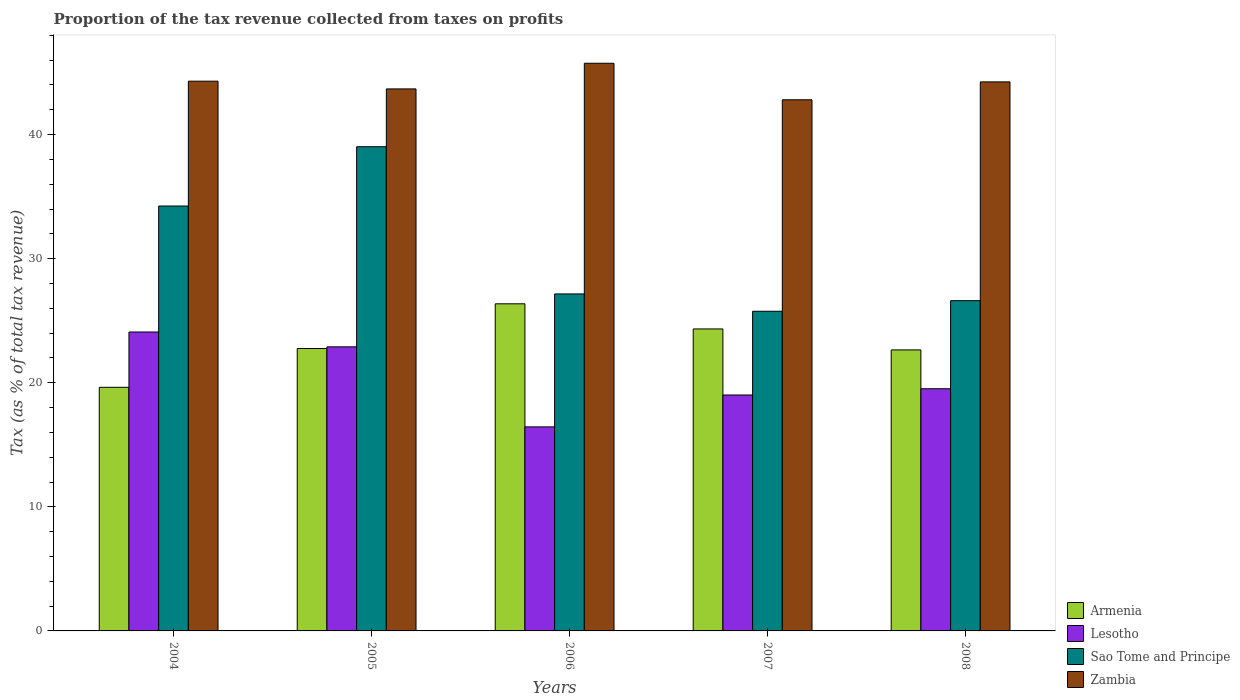How many different coloured bars are there?
Provide a short and direct response. 4. How many groups of bars are there?
Your answer should be very brief. 5. Are the number of bars on each tick of the X-axis equal?
Your answer should be very brief. Yes. In how many cases, is the number of bars for a given year not equal to the number of legend labels?
Offer a very short reply. 0. What is the proportion of the tax revenue collected in Zambia in 2008?
Your answer should be compact. 44.24. Across all years, what is the maximum proportion of the tax revenue collected in Lesotho?
Offer a terse response. 24.09. Across all years, what is the minimum proportion of the tax revenue collected in Armenia?
Make the answer very short. 19.63. In which year was the proportion of the tax revenue collected in Zambia minimum?
Your answer should be very brief. 2007. What is the total proportion of the tax revenue collected in Zambia in the graph?
Your answer should be compact. 220.77. What is the difference between the proportion of the tax revenue collected in Lesotho in 2004 and that in 2007?
Give a very brief answer. 5.07. What is the difference between the proportion of the tax revenue collected in Zambia in 2007 and the proportion of the tax revenue collected in Lesotho in 2005?
Make the answer very short. 19.91. What is the average proportion of the tax revenue collected in Armenia per year?
Ensure brevity in your answer.  23.15. In the year 2005, what is the difference between the proportion of the tax revenue collected in Lesotho and proportion of the tax revenue collected in Sao Tome and Principe?
Make the answer very short. -16.12. In how many years, is the proportion of the tax revenue collected in Sao Tome and Principe greater than 26 %?
Give a very brief answer. 4. What is the ratio of the proportion of the tax revenue collected in Zambia in 2006 to that in 2007?
Your answer should be compact. 1.07. What is the difference between the highest and the second highest proportion of the tax revenue collected in Sao Tome and Principe?
Provide a short and direct response. 4.78. What is the difference between the highest and the lowest proportion of the tax revenue collected in Lesotho?
Ensure brevity in your answer.  7.64. In how many years, is the proportion of the tax revenue collected in Lesotho greater than the average proportion of the tax revenue collected in Lesotho taken over all years?
Provide a succinct answer. 2. What does the 3rd bar from the left in 2008 represents?
Provide a short and direct response. Sao Tome and Principe. What does the 2nd bar from the right in 2007 represents?
Your response must be concise. Sao Tome and Principe. How many bars are there?
Keep it short and to the point. 20. Are all the bars in the graph horizontal?
Give a very brief answer. No. How many years are there in the graph?
Your response must be concise. 5. What is the difference between two consecutive major ticks on the Y-axis?
Give a very brief answer. 10. Are the values on the major ticks of Y-axis written in scientific E-notation?
Offer a very short reply. No. Does the graph contain grids?
Provide a succinct answer. No. Where does the legend appear in the graph?
Provide a short and direct response. Bottom right. How many legend labels are there?
Offer a very short reply. 4. What is the title of the graph?
Your answer should be very brief. Proportion of the tax revenue collected from taxes on profits. What is the label or title of the Y-axis?
Provide a short and direct response. Tax (as % of total tax revenue). What is the Tax (as % of total tax revenue) of Armenia in 2004?
Provide a succinct answer. 19.63. What is the Tax (as % of total tax revenue) in Lesotho in 2004?
Keep it short and to the point. 24.09. What is the Tax (as % of total tax revenue) in Sao Tome and Principe in 2004?
Your response must be concise. 34.24. What is the Tax (as % of total tax revenue) in Zambia in 2004?
Your answer should be very brief. 44.3. What is the Tax (as % of total tax revenue) in Armenia in 2005?
Provide a short and direct response. 22.76. What is the Tax (as % of total tax revenue) in Lesotho in 2005?
Keep it short and to the point. 22.89. What is the Tax (as % of total tax revenue) in Sao Tome and Principe in 2005?
Ensure brevity in your answer.  39.02. What is the Tax (as % of total tax revenue) in Zambia in 2005?
Your answer should be very brief. 43.68. What is the Tax (as % of total tax revenue) in Armenia in 2006?
Make the answer very short. 26.36. What is the Tax (as % of total tax revenue) in Lesotho in 2006?
Make the answer very short. 16.44. What is the Tax (as % of total tax revenue) of Sao Tome and Principe in 2006?
Provide a succinct answer. 27.16. What is the Tax (as % of total tax revenue) in Zambia in 2006?
Keep it short and to the point. 45.74. What is the Tax (as % of total tax revenue) in Armenia in 2007?
Give a very brief answer. 24.33. What is the Tax (as % of total tax revenue) in Lesotho in 2007?
Your answer should be compact. 19.01. What is the Tax (as % of total tax revenue) of Sao Tome and Principe in 2007?
Give a very brief answer. 25.76. What is the Tax (as % of total tax revenue) of Zambia in 2007?
Ensure brevity in your answer.  42.8. What is the Tax (as % of total tax revenue) in Armenia in 2008?
Provide a short and direct response. 22.64. What is the Tax (as % of total tax revenue) in Lesotho in 2008?
Your response must be concise. 19.52. What is the Tax (as % of total tax revenue) in Sao Tome and Principe in 2008?
Offer a terse response. 26.61. What is the Tax (as % of total tax revenue) in Zambia in 2008?
Ensure brevity in your answer.  44.24. Across all years, what is the maximum Tax (as % of total tax revenue) of Armenia?
Your response must be concise. 26.36. Across all years, what is the maximum Tax (as % of total tax revenue) of Lesotho?
Your answer should be compact. 24.09. Across all years, what is the maximum Tax (as % of total tax revenue) of Sao Tome and Principe?
Give a very brief answer. 39.02. Across all years, what is the maximum Tax (as % of total tax revenue) in Zambia?
Your response must be concise. 45.74. Across all years, what is the minimum Tax (as % of total tax revenue) in Armenia?
Offer a terse response. 19.63. Across all years, what is the minimum Tax (as % of total tax revenue) of Lesotho?
Provide a short and direct response. 16.44. Across all years, what is the minimum Tax (as % of total tax revenue) in Sao Tome and Principe?
Make the answer very short. 25.76. Across all years, what is the minimum Tax (as % of total tax revenue) of Zambia?
Keep it short and to the point. 42.8. What is the total Tax (as % of total tax revenue) in Armenia in the graph?
Your answer should be compact. 115.73. What is the total Tax (as % of total tax revenue) in Lesotho in the graph?
Your response must be concise. 101.95. What is the total Tax (as % of total tax revenue) in Sao Tome and Principe in the graph?
Offer a terse response. 152.78. What is the total Tax (as % of total tax revenue) in Zambia in the graph?
Your response must be concise. 220.77. What is the difference between the Tax (as % of total tax revenue) of Armenia in 2004 and that in 2005?
Provide a short and direct response. -3.13. What is the difference between the Tax (as % of total tax revenue) of Lesotho in 2004 and that in 2005?
Provide a succinct answer. 1.19. What is the difference between the Tax (as % of total tax revenue) of Sao Tome and Principe in 2004 and that in 2005?
Your answer should be compact. -4.78. What is the difference between the Tax (as % of total tax revenue) in Zambia in 2004 and that in 2005?
Make the answer very short. 0.62. What is the difference between the Tax (as % of total tax revenue) in Armenia in 2004 and that in 2006?
Make the answer very short. -6.73. What is the difference between the Tax (as % of total tax revenue) in Lesotho in 2004 and that in 2006?
Keep it short and to the point. 7.64. What is the difference between the Tax (as % of total tax revenue) in Sao Tome and Principe in 2004 and that in 2006?
Make the answer very short. 7.08. What is the difference between the Tax (as % of total tax revenue) in Zambia in 2004 and that in 2006?
Make the answer very short. -1.44. What is the difference between the Tax (as % of total tax revenue) of Armenia in 2004 and that in 2007?
Make the answer very short. -4.7. What is the difference between the Tax (as % of total tax revenue) in Lesotho in 2004 and that in 2007?
Provide a short and direct response. 5.07. What is the difference between the Tax (as % of total tax revenue) in Sao Tome and Principe in 2004 and that in 2007?
Your response must be concise. 8.48. What is the difference between the Tax (as % of total tax revenue) of Zambia in 2004 and that in 2007?
Keep it short and to the point. 1.5. What is the difference between the Tax (as % of total tax revenue) in Armenia in 2004 and that in 2008?
Your response must be concise. -3.01. What is the difference between the Tax (as % of total tax revenue) in Lesotho in 2004 and that in 2008?
Provide a succinct answer. 4.57. What is the difference between the Tax (as % of total tax revenue) of Sao Tome and Principe in 2004 and that in 2008?
Provide a succinct answer. 7.63. What is the difference between the Tax (as % of total tax revenue) in Zambia in 2004 and that in 2008?
Ensure brevity in your answer.  0.06. What is the difference between the Tax (as % of total tax revenue) of Armenia in 2005 and that in 2006?
Your answer should be compact. -3.6. What is the difference between the Tax (as % of total tax revenue) of Lesotho in 2005 and that in 2006?
Ensure brevity in your answer.  6.45. What is the difference between the Tax (as % of total tax revenue) of Sao Tome and Principe in 2005 and that in 2006?
Provide a succinct answer. 11.86. What is the difference between the Tax (as % of total tax revenue) in Zambia in 2005 and that in 2006?
Make the answer very short. -2.07. What is the difference between the Tax (as % of total tax revenue) in Armenia in 2005 and that in 2007?
Keep it short and to the point. -1.58. What is the difference between the Tax (as % of total tax revenue) in Lesotho in 2005 and that in 2007?
Your answer should be very brief. 3.88. What is the difference between the Tax (as % of total tax revenue) of Sao Tome and Principe in 2005 and that in 2007?
Keep it short and to the point. 13.26. What is the difference between the Tax (as % of total tax revenue) of Zambia in 2005 and that in 2007?
Give a very brief answer. 0.88. What is the difference between the Tax (as % of total tax revenue) of Armenia in 2005 and that in 2008?
Keep it short and to the point. 0.11. What is the difference between the Tax (as % of total tax revenue) of Lesotho in 2005 and that in 2008?
Give a very brief answer. 3.38. What is the difference between the Tax (as % of total tax revenue) in Sao Tome and Principe in 2005 and that in 2008?
Offer a terse response. 12.41. What is the difference between the Tax (as % of total tax revenue) in Zambia in 2005 and that in 2008?
Ensure brevity in your answer.  -0.57. What is the difference between the Tax (as % of total tax revenue) of Armenia in 2006 and that in 2007?
Keep it short and to the point. 2.03. What is the difference between the Tax (as % of total tax revenue) in Lesotho in 2006 and that in 2007?
Offer a very short reply. -2.57. What is the difference between the Tax (as % of total tax revenue) of Sao Tome and Principe in 2006 and that in 2007?
Provide a succinct answer. 1.4. What is the difference between the Tax (as % of total tax revenue) of Zambia in 2006 and that in 2007?
Make the answer very short. 2.94. What is the difference between the Tax (as % of total tax revenue) in Armenia in 2006 and that in 2008?
Your answer should be very brief. 3.72. What is the difference between the Tax (as % of total tax revenue) in Lesotho in 2006 and that in 2008?
Provide a short and direct response. -3.07. What is the difference between the Tax (as % of total tax revenue) of Sao Tome and Principe in 2006 and that in 2008?
Provide a succinct answer. 0.54. What is the difference between the Tax (as % of total tax revenue) of Zambia in 2006 and that in 2008?
Your response must be concise. 1.5. What is the difference between the Tax (as % of total tax revenue) in Armenia in 2007 and that in 2008?
Offer a terse response. 1.69. What is the difference between the Tax (as % of total tax revenue) of Lesotho in 2007 and that in 2008?
Provide a succinct answer. -0.5. What is the difference between the Tax (as % of total tax revenue) of Sao Tome and Principe in 2007 and that in 2008?
Make the answer very short. -0.85. What is the difference between the Tax (as % of total tax revenue) in Zambia in 2007 and that in 2008?
Your answer should be very brief. -1.44. What is the difference between the Tax (as % of total tax revenue) in Armenia in 2004 and the Tax (as % of total tax revenue) in Lesotho in 2005?
Keep it short and to the point. -3.26. What is the difference between the Tax (as % of total tax revenue) in Armenia in 2004 and the Tax (as % of total tax revenue) in Sao Tome and Principe in 2005?
Your answer should be very brief. -19.39. What is the difference between the Tax (as % of total tax revenue) of Armenia in 2004 and the Tax (as % of total tax revenue) of Zambia in 2005?
Offer a very short reply. -24.05. What is the difference between the Tax (as % of total tax revenue) in Lesotho in 2004 and the Tax (as % of total tax revenue) in Sao Tome and Principe in 2005?
Your answer should be compact. -14.93. What is the difference between the Tax (as % of total tax revenue) of Lesotho in 2004 and the Tax (as % of total tax revenue) of Zambia in 2005?
Give a very brief answer. -19.59. What is the difference between the Tax (as % of total tax revenue) in Sao Tome and Principe in 2004 and the Tax (as % of total tax revenue) in Zambia in 2005?
Give a very brief answer. -9.44. What is the difference between the Tax (as % of total tax revenue) of Armenia in 2004 and the Tax (as % of total tax revenue) of Lesotho in 2006?
Give a very brief answer. 3.19. What is the difference between the Tax (as % of total tax revenue) in Armenia in 2004 and the Tax (as % of total tax revenue) in Sao Tome and Principe in 2006?
Your response must be concise. -7.52. What is the difference between the Tax (as % of total tax revenue) in Armenia in 2004 and the Tax (as % of total tax revenue) in Zambia in 2006?
Provide a short and direct response. -26.11. What is the difference between the Tax (as % of total tax revenue) in Lesotho in 2004 and the Tax (as % of total tax revenue) in Sao Tome and Principe in 2006?
Provide a short and direct response. -3.07. What is the difference between the Tax (as % of total tax revenue) of Lesotho in 2004 and the Tax (as % of total tax revenue) of Zambia in 2006?
Give a very brief answer. -21.66. What is the difference between the Tax (as % of total tax revenue) of Sao Tome and Principe in 2004 and the Tax (as % of total tax revenue) of Zambia in 2006?
Keep it short and to the point. -11.51. What is the difference between the Tax (as % of total tax revenue) in Armenia in 2004 and the Tax (as % of total tax revenue) in Lesotho in 2007?
Offer a terse response. 0.62. What is the difference between the Tax (as % of total tax revenue) of Armenia in 2004 and the Tax (as % of total tax revenue) of Sao Tome and Principe in 2007?
Give a very brief answer. -6.13. What is the difference between the Tax (as % of total tax revenue) of Armenia in 2004 and the Tax (as % of total tax revenue) of Zambia in 2007?
Make the answer very short. -23.17. What is the difference between the Tax (as % of total tax revenue) of Lesotho in 2004 and the Tax (as % of total tax revenue) of Sao Tome and Principe in 2007?
Your answer should be very brief. -1.67. What is the difference between the Tax (as % of total tax revenue) in Lesotho in 2004 and the Tax (as % of total tax revenue) in Zambia in 2007?
Your response must be concise. -18.71. What is the difference between the Tax (as % of total tax revenue) of Sao Tome and Principe in 2004 and the Tax (as % of total tax revenue) of Zambia in 2007?
Offer a terse response. -8.56. What is the difference between the Tax (as % of total tax revenue) in Armenia in 2004 and the Tax (as % of total tax revenue) in Lesotho in 2008?
Your response must be concise. 0.12. What is the difference between the Tax (as % of total tax revenue) of Armenia in 2004 and the Tax (as % of total tax revenue) of Sao Tome and Principe in 2008?
Ensure brevity in your answer.  -6.98. What is the difference between the Tax (as % of total tax revenue) of Armenia in 2004 and the Tax (as % of total tax revenue) of Zambia in 2008?
Provide a succinct answer. -24.61. What is the difference between the Tax (as % of total tax revenue) of Lesotho in 2004 and the Tax (as % of total tax revenue) of Sao Tome and Principe in 2008?
Your answer should be very brief. -2.52. What is the difference between the Tax (as % of total tax revenue) of Lesotho in 2004 and the Tax (as % of total tax revenue) of Zambia in 2008?
Give a very brief answer. -20.16. What is the difference between the Tax (as % of total tax revenue) of Sao Tome and Principe in 2004 and the Tax (as % of total tax revenue) of Zambia in 2008?
Offer a very short reply. -10. What is the difference between the Tax (as % of total tax revenue) of Armenia in 2005 and the Tax (as % of total tax revenue) of Lesotho in 2006?
Ensure brevity in your answer.  6.31. What is the difference between the Tax (as % of total tax revenue) of Armenia in 2005 and the Tax (as % of total tax revenue) of Sao Tome and Principe in 2006?
Give a very brief answer. -4.4. What is the difference between the Tax (as % of total tax revenue) of Armenia in 2005 and the Tax (as % of total tax revenue) of Zambia in 2006?
Keep it short and to the point. -22.99. What is the difference between the Tax (as % of total tax revenue) in Lesotho in 2005 and the Tax (as % of total tax revenue) in Sao Tome and Principe in 2006?
Provide a short and direct response. -4.26. What is the difference between the Tax (as % of total tax revenue) of Lesotho in 2005 and the Tax (as % of total tax revenue) of Zambia in 2006?
Offer a terse response. -22.85. What is the difference between the Tax (as % of total tax revenue) of Sao Tome and Principe in 2005 and the Tax (as % of total tax revenue) of Zambia in 2006?
Keep it short and to the point. -6.73. What is the difference between the Tax (as % of total tax revenue) of Armenia in 2005 and the Tax (as % of total tax revenue) of Lesotho in 2007?
Keep it short and to the point. 3.74. What is the difference between the Tax (as % of total tax revenue) in Armenia in 2005 and the Tax (as % of total tax revenue) in Sao Tome and Principe in 2007?
Make the answer very short. -3. What is the difference between the Tax (as % of total tax revenue) of Armenia in 2005 and the Tax (as % of total tax revenue) of Zambia in 2007?
Provide a short and direct response. -20.04. What is the difference between the Tax (as % of total tax revenue) of Lesotho in 2005 and the Tax (as % of total tax revenue) of Sao Tome and Principe in 2007?
Make the answer very short. -2.87. What is the difference between the Tax (as % of total tax revenue) of Lesotho in 2005 and the Tax (as % of total tax revenue) of Zambia in 2007?
Keep it short and to the point. -19.91. What is the difference between the Tax (as % of total tax revenue) of Sao Tome and Principe in 2005 and the Tax (as % of total tax revenue) of Zambia in 2007?
Provide a succinct answer. -3.78. What is the difference between the Tax (as % of total tax revenue) of Armenia in 2005 and the Tax (as % of total tax revenue) of Lesotho in 2008?
Ensure brevity in your answer.  3.24. What is the difference between the Tax (as % of total tax revenue) of Armenia in 2005 and the Tax (as % of total tax revenue) of Sao Tome and Principe in 2008?
Provide a succinct answer. -3.85. What is the difference between the Tax (as % of total tax revenue) of Armenia in 2005 and the Tax (as % of total tax revenue) of Zambia in 2008?
Make the answer very short. -21.49. What is the difference between the Tax (as % of total tax revenue) in Lesotho in 2005 and the Tax (as % of total tax revenue) in Sao Tome and Principe in 2008?
Your answer should be very brief. -3.72. What is the difference between the Tax (as % of total tax revenue) of Lesotho in 2005 and the Tax (as % of total tax revenue) of Zambia in 2008?
Provide a succinct answer. -21.35. What is the difference between the Tax (as % of total tax revenue) in Sao Tome and Principe in 2005 and the Tax (as % of total tax revenue) in Zambia in 2008?
Provide a succinct answer. -5.23. What is the difference between the Tax (as % of total tax revenue) in Armenia in 2006 and the Tax (as % of total tax revenue) in Lesotho in 2007?
Your answer should be compact. 7.35. What is the difference between the Tax (as % of total tax revenue) in Armenia in 2006 and the Tax (as % of total tax revenue) in Sao Tome and Principe in 2007?
Make the answer very short. 0.6. What is the difference between the Tax (as % of total tax revenue) of Armenia in 2006 and the Tax (as % of total tax revenue) of Zambia in 2007?
Provide a succinct answer. -16.44. What is the difference between the Tax (as % of total tax revenue) of Lesotho in 2006 and the Tax (as % of total tax revenue) of Sao Tome and Principe in 2007?
Your answer should be compact. -9.32. What is the difference between the Tax (as % of total tax revenue) in Lesotho in 2006 and the Tax (as % of total tax revenue) in Zambia in 2007?
Make the answer very short. -26.36. What is the difference between the Tax (as % of total tax revenue) in Sao Tome and Principe in 2006 and the Tax (as % of total tax revenue) in Zambia in 2007?
Your answer should be very brief. -15.65. What is the difference between the Tax (as % of total tax revenue) of Armenia in 2006 and the Tax (as % of total tax revenue) of Lesotho in 2008?
Offer a terse response. 6.84. What is the difference between the Tax (as % of total tax revenue) in Armenia in 2006 and the Tax (as % of total tax revenue) in Sao Tome and Principe in 2008?
Your answer should be compact. -0.25. What is the difference between the Tax (as % of total tax revenue) of Armenia in 2006 and the Tax (as % of total tax revenue) of Zambia in 2008?
Give a very brief answer. -17.88. What is the difference between the Tax (as % of total tax revenue) of Lesotho in 2006 and the Tax (as % of total tax revenue) of Sao Tome and Principe in 2008?
Ensure brevity in your answer.  -10.17. What is the difference between the Tax (as % of total tax revenue) of Lesotho in 2006 and the Tax (as % of total tax revenue) of Zambia in 2008?
Provide a short and direct response. -27.8. What is the difference between the Tax (as % of total tax revenue) in Sao Tome and Principe in 2006 and the Tax (as % of total tax revenue) in Zambia in 2008?
Ensure brevity in your answer.  -17.09. What is the difference between the Tax (as % of total tax revenue) of Armenia in 2007 and the Tax (as % of total tax revenue) of Lesotho in 2008?
Provide a succinct answer. 4.82. What is the difference between the Tax (as % of total tax revenue) in Armenia in 2007 and the Tax (as % of total tax revenue) in Sao Tome and Principe in 2008?
Give a very brief answer. -2.28. What is the difference between the Tax (as % of total tax revenue) of Armenia in 2007 and the Tax (as % of total tax revenue) of Zambia in 2008?
Offer a very short reply. -19.91. What is the difference between the Tax (as % of total tax revenue) of Lesotho in 2007 and the Tax (as % of total tax revenue) of Sao Tome and Principe in 2008?
Give a very brief answer. -7.6. What is the difference between the Tax (as % of total tax revenue) of Lesotho in 2007 and the Tax (as % of total tax revenue) of Zambia in 2008?
Your response must be concise. -25.23. What is the difference between the Tax (as % of total tax revenue) of Sao Tome and Principe in 2007 and the Tax (as % of total tax revenue) of Zambia in 2008?
Ensure brevity in your answer.  -18.48. What is the average Tax (as % of total tax revenue) of Armenia per year?
Keep it short and to the point. 23.15. What is the average Tax (as % of total tax revenue) of Lesotho per year?
Give a very brief answer. 20.39. What is the average Tax (as % of total tax revenue) in Sao Tome and Principe per year?
Your answer should be compact. 30.56. What is the average Tax (as % of total tax revenue) of Zambia per year?
Give a very brief answer. 44.15. In the year 2004, what is the difference between the Tax (as % of total tax revenue) in Armenia and Tax (as % of total tax revenue) in Lesotho?
Your answer should be compact. -4.46. In the year 2004, what is the difference between the Tax (as % of total tax revenue) in Armenia and Tax (as % of total tax revenue) in Sao Tome and Principe?
Your answer should be compact. -14.61. In the year 2004, what is the difference between the Tax (as % of total tax revenue) in Armenia and Tax (as % of total tax revenue) in Zambia?
Offer a terse response. -24.67. In the year 2004, what is the difference between the Tax (as % of total tax revenue) of Lesotho and Tax (as % of total tax revenue) of Sao Tome and Principe?
Your answer should be very brief. -10.15. In the year 2004, what is the difference between the Tax (as % of total tax revenue) in Lesotho and Tax (as % of total tax revenue) in Zambia?
Make the answer very short. -20.21. In the year 2004, what is the difference between the Tax (as % of total tax revenue) of Sao Tome and Principe and Tax (as % of total tax revenue) of Zambia?
Provide a short and direct response. -10.06. In the year 2005, what is the difference between the Tax (as % of total tax revenue) of Armenia and Tax (as % of total tax revenue) of Lesotho?
Provide a short and direct response. -0.14. In the year 2005, what is the difference between the Tax (as % of total tax revenue) in Armenia and Tax (as % of total tax revenue) in Sao Tome and Principe?
Offer a very short reply. -16.26. In the year 2005, what is the difference between the Tax (as % of total tax revenue) of Armenia and Tax (as % of total tax revenue) of Zambia?
Provide a succinct answer. -20.92. In the year 2005, what is the difference between the Tax (as % of total tax revenue) in Lesotho and Tax (as % of total tax revenue) in Sao Tome and Principe?
Your answer should be very brief. -16.12. In the year 2005, what is the difference between the Tax (as % of total tax revenue) of Lesotho and Tax (as % of total tax revenue) of Zambia?
Keep it short and to the point. -20.78. In the year 2005, what is the difference between the Tax (as % of total tax revenue) of Sao Tome and Principe and Tax (as % of total tax revenue) of Zambia?
Your response must be concise. -4.66. In the year 2006, what is the difference between the Tax (as % of total tax revenue) of Armenia and Tax (as % of total tax revenue) of Lesotho?
Make the answer very short. 9.92. In the year 2006, what is the difference between the Tax (as % of total tax revenue) of Armenia and Tax (as % of total tax revenue) of Sao Tome and Principe?
Offer a very short reply. -0.8. In the year 2006, what is the difference between the Tax (as % of total tax revenue) in Armenia and Tax (as % of total tax revenue) in Zambia?
Ensure brevity in your answer.  -19.38. In the year 2006, what is the difference between the Tax (as % of total tax revenue) of Lesotho and Tax (as % of total tax revenue) of Sao Tome and Principe?
Keep it short and to the point. -10.71. In the year 2006, what is the difference between the Tax (as % of total tax revenue) of Lesotho and Tax (as % of total tax revenue) of Zambia?
Your response must be concise. -29.3. In the year 2006, what is the difference between the Tax (as % of total tax revenue) in Sao Tome and Principe and Tax (as % of total tax revenue) in Zambia?
Offer a very short reply. -18.59. In the year 2007, what is the difference between the Tax (as % of total tax revenue) in Armenia and Tax (as % of total tax revenue) in Lesotho?
Provide a short and direct response. 5.32. In the year 2007, what is the difference between the Tax (as % of total tax revenue) of Armenia and Tax (as % of total tax revenue) of Sao Tome and Principe?
Your answer should be compact. -1.43. In the year 2007, what is the difference between the Tax (as % of total tax revenue) in Armenia and Tax (as % of total tax revenue) in Zambia?
Your response must be concise. -18.47. In the year 2007, what is the difference between the Tax (as % of total tax revenue) in Lesotho and Tax (as % of total tax revenue) in Sao Tome and Principe?
Provide a succinct answer. -6.75. In the year 2007, what is the difference between the Tax (as % of total tax revenue) of Lesotho and Tax (as % of total tax revenue) of Zambia?
Ensure brevity in your answer.  -23.79. In the year 2007, what is the difference between the Tax (as % of total tax revenue) in Sao Tome and Principe and Tax (as % of total tax revenue) in Zambia?
Give a very brief answer. -17.04. In the year 2008, what is the difference between the Tax (as % of total tax revenue) of Armenia and Tax (as % of total tax revenue) of Lesotho?
Your answer should be compact. 3.13. In the year 2008, what is the difference between the Tax (as % of total tax revenue) in Armenia and Tax (as % of total tax revenue) in Sao Tome and Principe?
Ensure brevity in your answer.  -3.97. In the year 2008, what is the difference between the Tax (as % of total tax revenue) of Armenia and Tax (as % of total tax revenue) of Zambia?
Provide a short and direct response. -21.6. In the year 2008, what is the difference between the Tax (as % of total tax revenue) of Lesotho and Tax (as % of total tax revenue) of Sao Tome and Principe?
Offer a very short reply. -7.1. In the year 2008, what is the difference between the Tax (as % of total tax revenue) in Lesotho and Tax (as % of total tax revenue) in Zambia?
Provide a succinct answer. -24.73. In the year 2008, what is the difference between the Tax (as % of total tax revenue) in Sao Tome and Principe and Tax (as % of total tax revenue) in Zambia?
Your response must be concise. -17.63. What is the ratio of the Tax (as % of total tax revenue) in Armenia in 2004 to that in 2005?
Your answer should be very brief. 0.86. What is the ratio of the Tax (as % of total tax revenue) of Lesotho in 2004 to that in 2005?
Provide a succinct answer. 1.05. What is the ratio of the Tax (as % of total tax revenue) in Sao Tome and Principe in 2004 to that in 2005?
Offer a terse response. 0.88. What is the ratio of the Tax (as % of total tax revenue) of Zambia in 2004 to that in 2005?
Ensure brevity in your answer.  1.01. What is the ratio of the Tax (as % of total tax revenue) of Armenia in 2004 to that in 2006?
Keep it short and to the point. 0.74. What is the ratio of the Tax (as % of total tax revenue) in Lesotho in 2004 to that in 2006?
Offer a very short reply. 1.46. What is the ratio of the Tax (as % of total tax revenue) in Sao Tome and Principe in 2004 to that in 2006?
Offer a terse response. 1.26. What is the ratio of the Tax (as % of total tax revenue) of Zambia in 2004 to that in 2006?
Ensure brevity in your answer.  0.97. What is the ratio of the Tax (as % of total tax revenue) in Armenia in 2004 to that in 2007?
Provide a succinct answer. 0.81. What is the ratio of the Tax (as % of total tax revenue) in Lesotho in 2004 to that in 2007?
Give a very brief answer. 1.27. What is the ratio of the Tax (as % of total tax revenue) in Sao Tome and Principe in 2004 to that in 2007?
Your response must be concise. 1.33. What is the ratio of the Tax (as % of total tax revenue) of Zambia in 2004 to that in 2007?
Provide a short and direct response. 1.03. What is the ratio of the Tax (as % of total tax revenue) of Armenia in 2004 to that in 2008?
Keep it short and to the point. 0.87. What is the ratio of the Tax (as % of total tax revenue) in Lesotho in 2004 to that in 2008?
Your response must be concise. 1.23. What is the ratio of the Tax (as % of total tax revenue) in Sao Tome and Principe in 2004 to that in 2008?
Provide a succinct answer. 1.29. What is the ratio of the Tax (as % of total tax revenue) in Zambia in 2004 to that in 2008?
Give a very brief answer. 1. What is the ratio of the Tax (as % of total tax revenue) in Armenia in 2005 to that in 2006?
Your answer should be very brief. 0.86. What is the ratio of the Tax (as % of total tax revenue) in Lesotho in 2005 to that in 2006?
Offer a terse response. 1.39. What is the ratio of the Tax (as % of total tax revenue) of Sao Tome and Principe in 2005 to that in 2006?
Offer a very short reply. 1.44. What is the ratio of the Tax (as % of total tax revenue) of Zambia in 2005 to that in 2006?
Give a very brief answer. 0.95. What is the ratio of the Tax (as % of total tax revenue) of Armenia in 2005 to that in 2007?
Ensure brevity in your answer.  0.94. What is the ratio of the Tax (as % of total tax revenue) in Lesotho in 2005 to that in 2007?
Make the answer very short. 1.2. What is the ratio of the Tax (as % of total tax revenue) in Sao Tome and Principe in 2005 to that in 2007?
Your response must be concise. 1.51. What is the ratio of the Tax (as % of total tax revenue) of Zambia in 2005 to that in 2007?
Provide a short and direct response. 1.02. What is the ratio of the Tax (as % of total tax revenue) of Lesotho in 2005 to that in 2008?
Give a very brief answer. 1.17. What is the ratio of the Tax (as % of total tax revenue) of Sao Tome and Principe in 2005 to that in 2008?
Offer a very short reply. 1.47. What is the ratio of the Tax (as % of total tax revenue) of Zambia in 2005 to that in 2008?
Your response must be concise. 0.99. What is the ratio of the Tax (as % of total tax revenue) of Armenia in 2006 to that in 2007?
Offer a very short reply. 1.08. What is the ratio of the Tax (as % of total tax revenue) in Lesotho in 2006 to that in 2007?
Your response must be concise. 0.86. What is the ratio of the Tax (as % of total tax revenue) in Sao Tome and Principe in 2006 to that in 2007?
Offer a very short reply. 1.05. What is the ratio of the Tax (as % of total tax revenue) of Zambia in 2006 to that in 2007?
Offer a terse response. 1.07. What is the ratio of the Tax (as % of total tax revenue) of Armenia in 2006 to that in 2008?
Make the answer very short. 1.16. What is the ratio of the Tax (as % of total tax revenue) of Lesotho in 2006 to that in 2008?
Your answer should be compact. 0.84. What is the ratio of the Tax (as % of total tax revenue) in Sao Tome and Principe in 2006 to that in 2008?
Provide a short and direct response. 1.02. What is the ratio of the Tax (as % of total tax revenue) in Zambia in 2006 to that in 2008?
Provide a succinct answer. 1.03. What is the ratio of the Tax (as % of total tax revenue) of Armenia in 2007 to that in 2008?
Make the answer very short. 1.07. What is the ratio of the Tax (as % of total tax revenue) of Lesotho in 2007 to that in 2008?
Offer a very short reply. 0.97. What is the ratio of the Tax (as % of total tax revenue) of Zambia in 2007 to that in 2008?
Make the answer very short. 0.97. What is the difference between the highest and the second highest Tax (as % of total tax revenue) of Armenia?
Your answer should be compact. 2.03. What is the difference between the highest and the second highest Tax (as % of total tax revenue) in Lesotho?
Your answer should be compact. 1.19. What is the difference between the highest and the second highest Tax (as % of total tax revenue) in Sao Tome and Principe?
Make the answer very short. 4.78. What is the difference between the highest and the second highest Tax (as % of total tax revenue) of Zambia?
Your response must be concise. 1.44. What is the difference between the highest and the lowest Tax (as % of total tax revenue) of Armenia?
Your answer should be compact. 6.73. What is the difference between the highest and the lowest Tax (as % of total tax revenue) of Lesotho?
Keep it short and to the point. 7.64. What is the difference between the highest and the lowest Tax (as % of total tax revenue) in Sao Tome and Principe?
Offer a terse response. 13.26. What is the difference between the highest and the lowest Tax (as % of total tax revenue) of Zambia?
Your response must be concise. 2.94. 